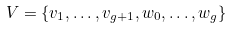<formula> <loc_0><loc_0><loc_500><loc_500>V = \{ v _ { 1 } , \dots , v _ { g + 1 } , w _ { 0 } , \dots , w _ { g } \}</formula> 